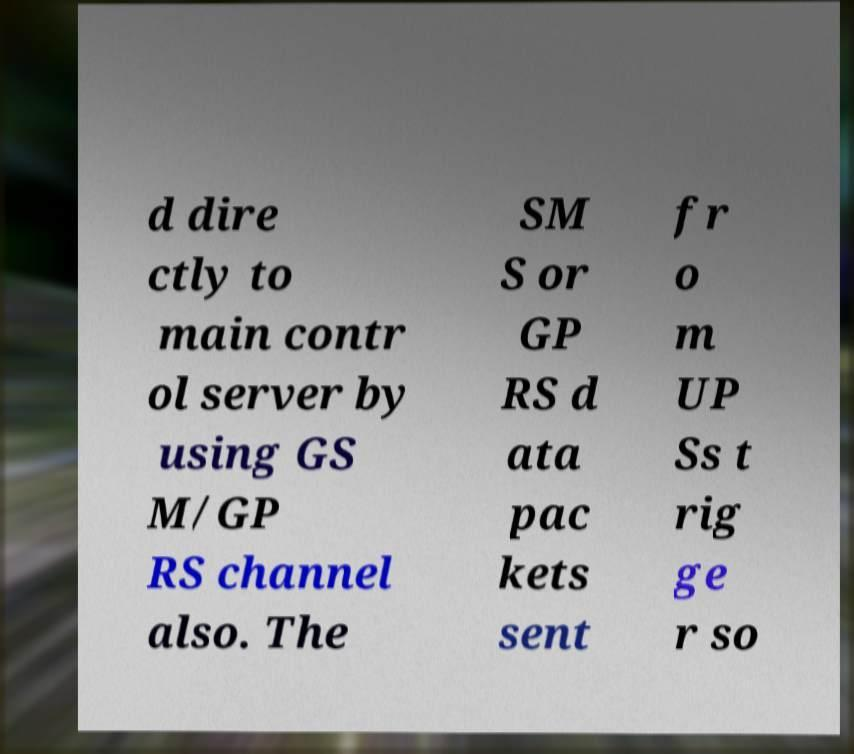What messages or text are displayed in this image? I need them in a readable, typed format. d dire ctly to main contr ol server by using GS M/GP RS channel also. The SM S or GP RS d ata pac kets sent fr o m UP Ss t rig ge r so 